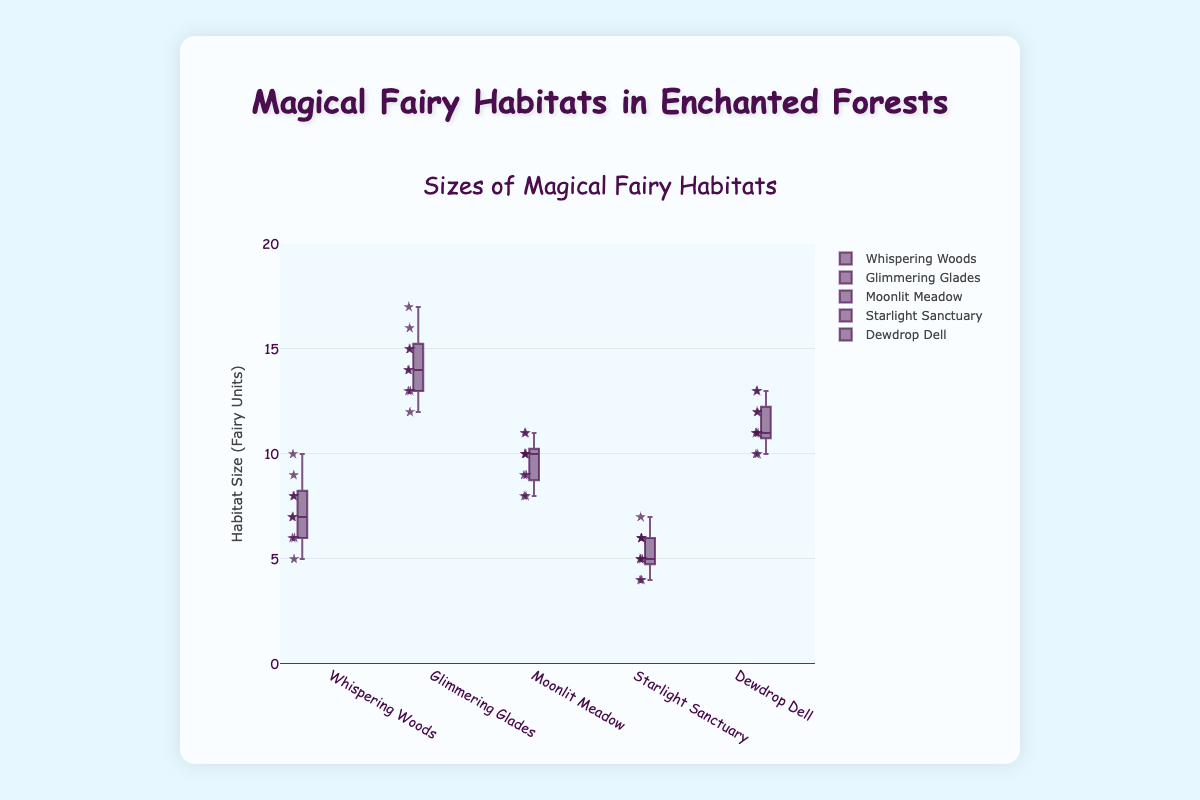What is the title of the plot? The title is displayed prominently at the top of the plot. It is usually used to understand what the figure is about.
Answer: Sizes of Magical Fairy Habitats What is the range of the y-axis? The range of the y-axis can be seen on the left side of the plot and defines the scope of the habitat sizes.
Answer: 0 to 20 In which forest is the largest single habitat size recorded, and what is its size? The largest single habitat size can be identified by finding the highest individual data point in the box plots for all forests.
Answer: Glimmering Glades, Size 17 Which enchanted forest has the smallest median habitat size? The median of each box plot is indicated by the line within the box. Compare the medians to find the smallest.
Answer: Starlight Sanctuary How many data points are shown for Dewdrop Dell? The number of data points is determined by counting the individual points shown for Dewdrop Dell in the plot.
Answer: 9 What is the interquartile range (IQR) for Moonlit Meadow? The IQR is calculated by subtracting the first quartile (Q1) from the third quartile (Q3), these are represented by the edges of the box.
Answer: 3 (Q3 = 10.5, Q1 = 7.5) Which forest has the widest spread of data points, and how can you tell? The spread is indicative by the range between the smallest and largest data points. Look at the range of whiskers for each forest.
Answer: Glimmering Glades Compare the median sizes of habitats in Whispering Woods and Starlight Sanctuary. To compare medians, find the line within each respective box and compare their positions or values.
Answer: Whispering Woods has a larger median size than Starlight Sanctuary Is there any forest that shows the same range for both the upper whisker and the lower whisker? Compare the lengths of the upper and lower whiskers for each forest to determine if they are equal.
Answer: No, all forests have different upper and lower whisker ranges 